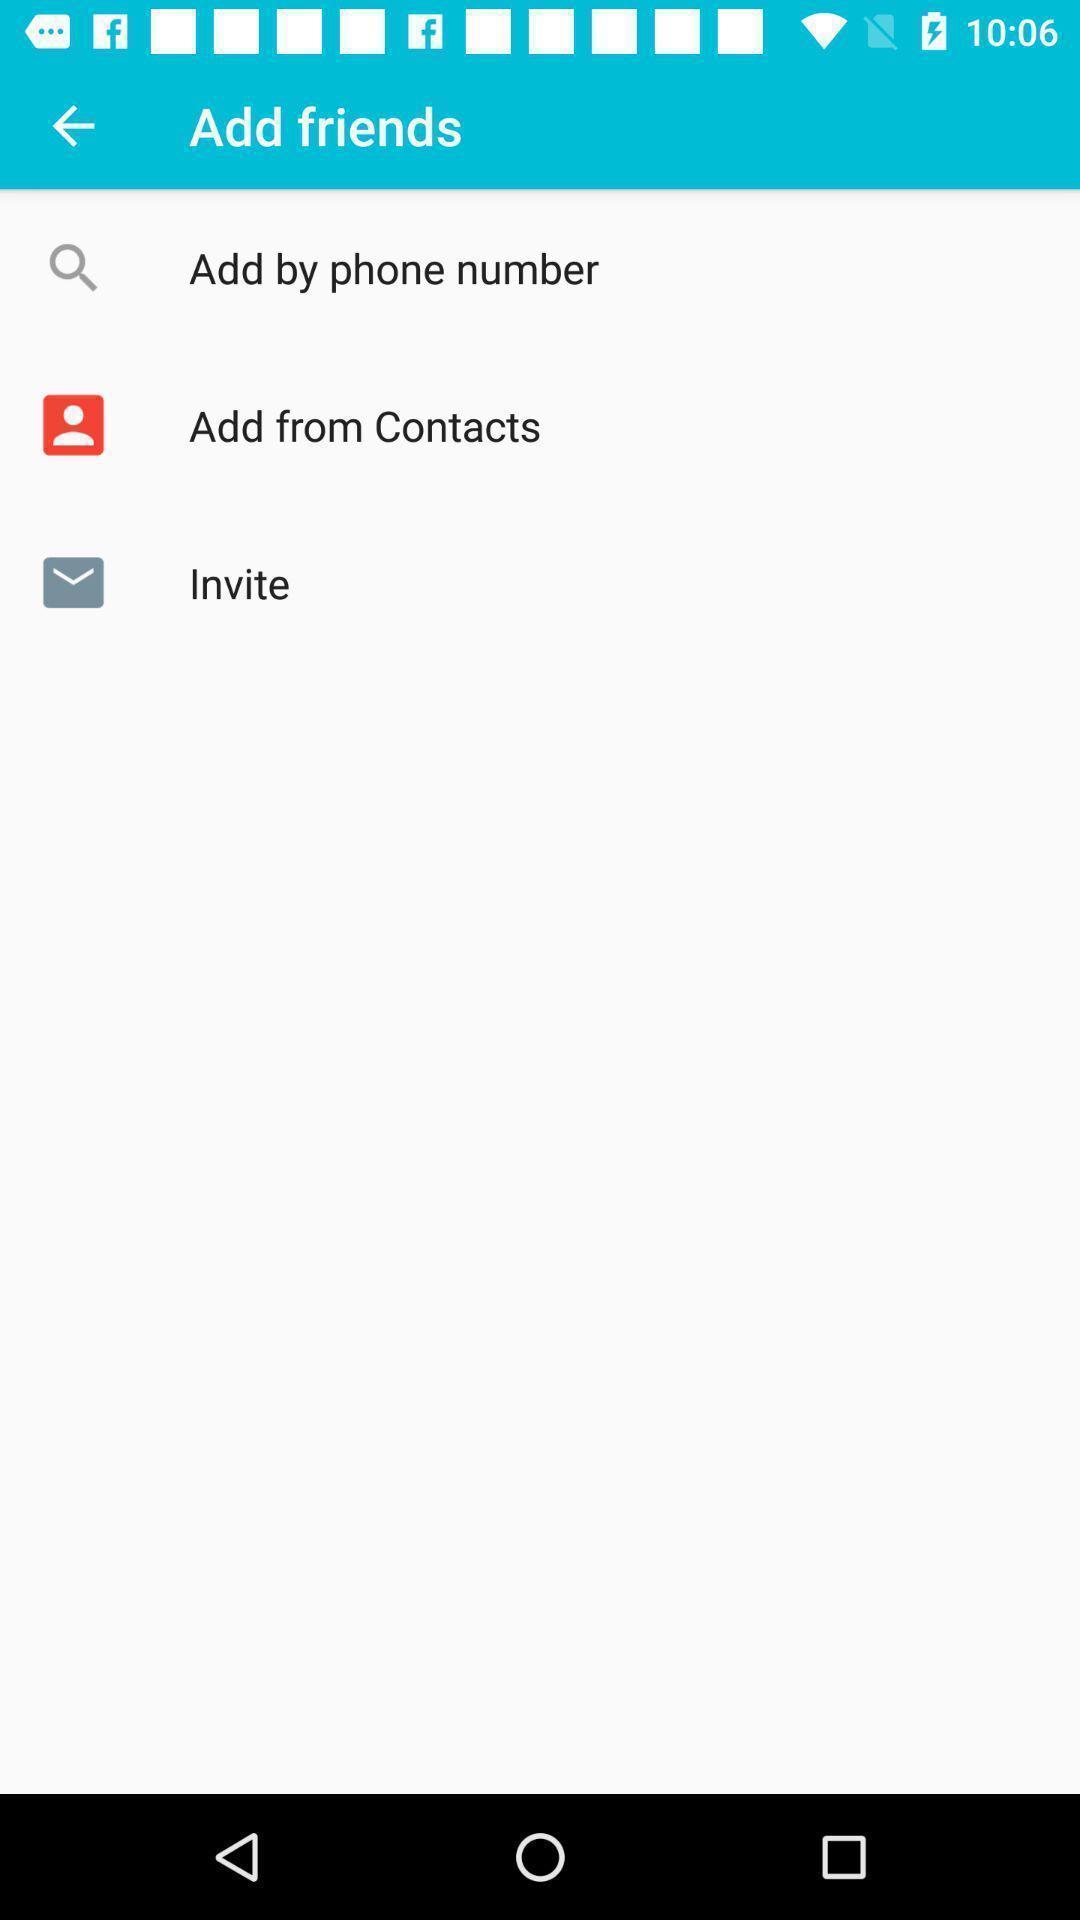Explain the elements present in this screenshot. Screen shows to add friends. 